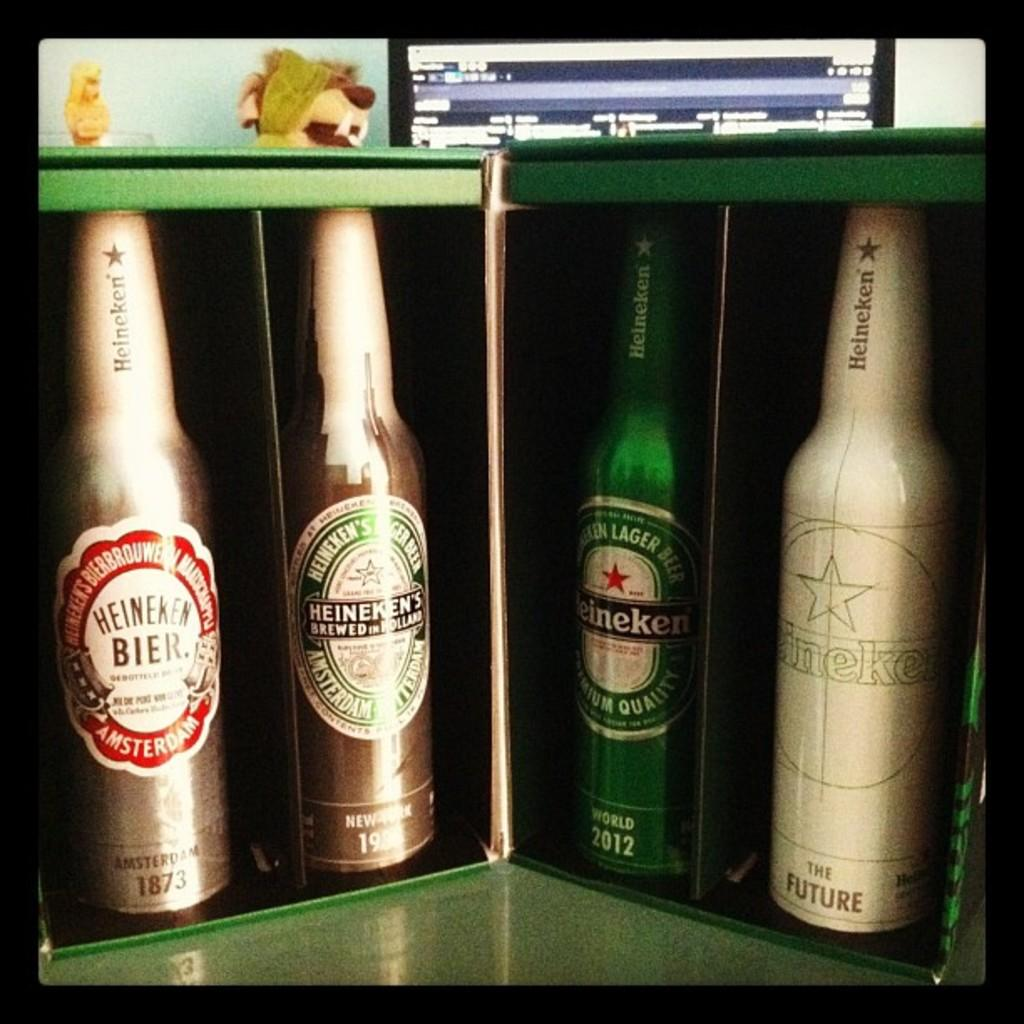Provide a one-sentence caption for the provided image. Four different bottles of Heineken beer are in a display. 